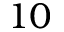<formula> <loc_0><loc_0><loc_500><loc_500>1 0</formula> 